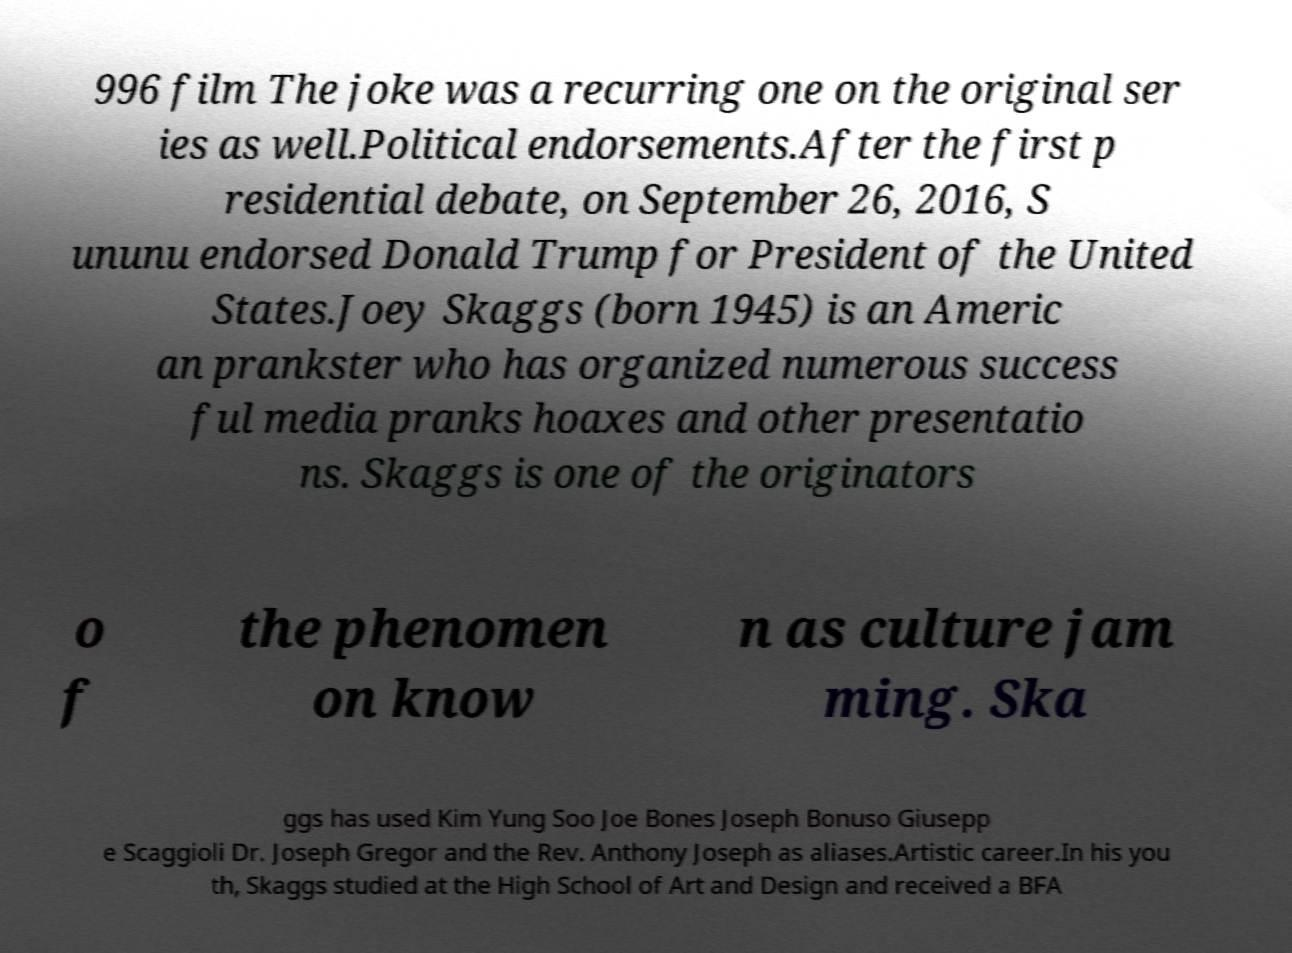I need the written content from this picture converted into text. Can you do that? 996 film The joke was a recurring one on the original ser ies as well.Political endorsements.After the first p residential debate, on September 26, 2016, S ununu endorsed Donald Trump for President of the United States.Joey Skaggs (born 1945) is an Americ an prankster who has organized numerous success ful media pranks hoaxes and other presentatio ns. Skaggs is one of the originators o f the phenomen on know n as culture jam ming. Ska ggs has used Kim Yung Soo Joe Bones Joseph Bonuso Giusepp e Scaggioli Dr. Joseph Gregor and the Rev. Anthony Joseph as aliases.Artistic career.In his you th, Skaggs studied at the High School of Art and Design and received a BFA 